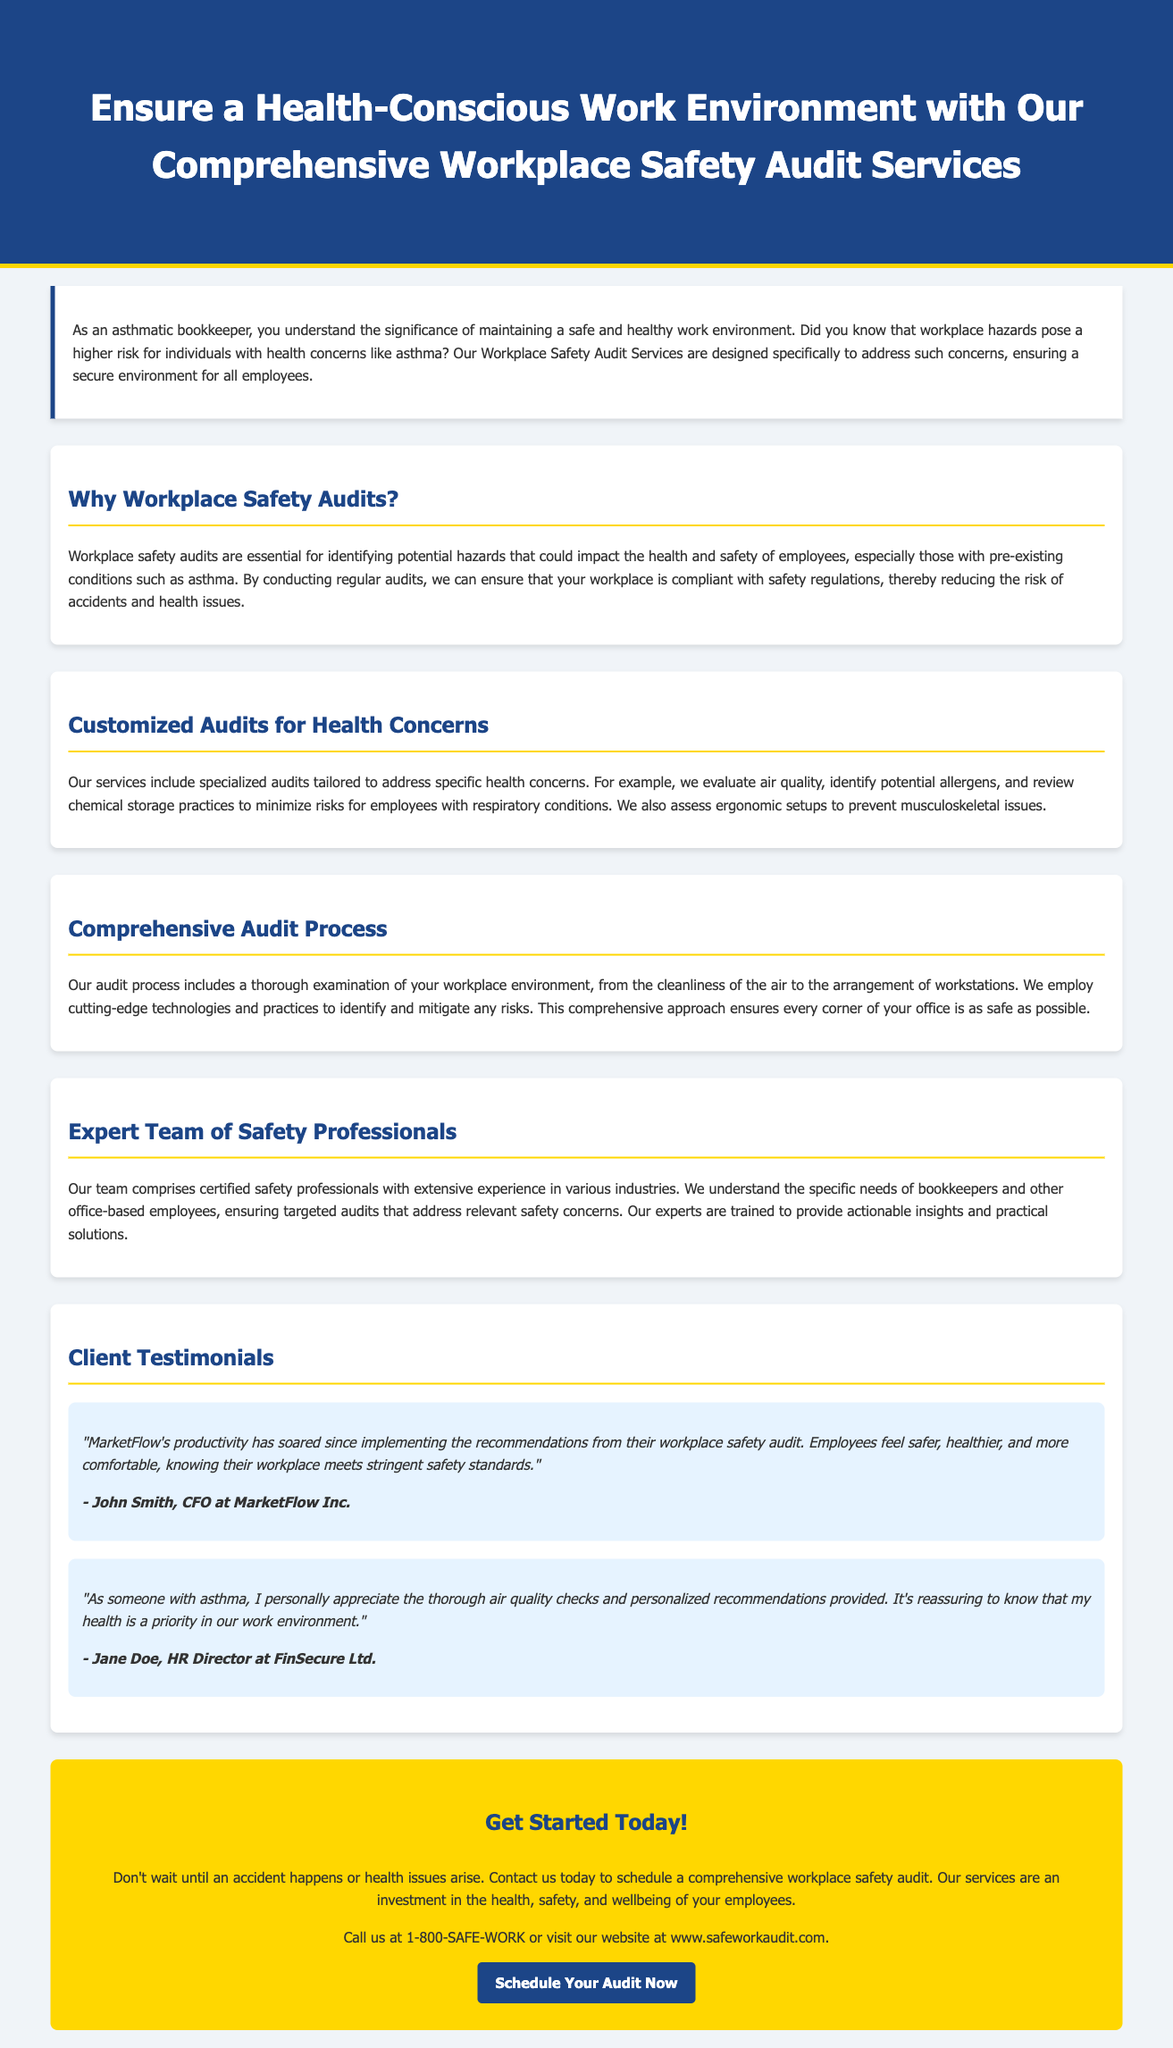What is the main service offered? The main service offered is a safety audit for workplaces to ensure health and safety, particularly for employees with concerns.
Answer: Workplace Safety Audit Services What specific health concern is highlighted? The advertisement focuses on asthma as a specific concern that the audits will address.
Answer: Asthma What type of professionals conduct the audits? The audits are conducted by certified safety professionals with extensive experience.
Answer: Certified safety professionals What is included in the comprehensive audit process? The audit process includes a thorough examination of various aspects of the workplace, including air quality and workstation arrangements.
Answer: Thorough examination What phone number can be called for scheduling an audit? The advertisement provides a specific phone number for inquiries.
Answer: 1-800-SAFE-WORK What is one benefit mentioned from a client testimonial? The testimonial highlights increased employee safety and health as a direct benefit of implementing audit recommendations.
Answer: Productivity has soared How is the audit process tailored? The audit process is tailored to include specialized evaluations that address specific health concerns like air quality and allergens.
Answer: Customized audits What is the call to action provided? The advertisement urges readers to take immediate action to schedule a safety audit.
Answer: Schedule Your Audit Now 